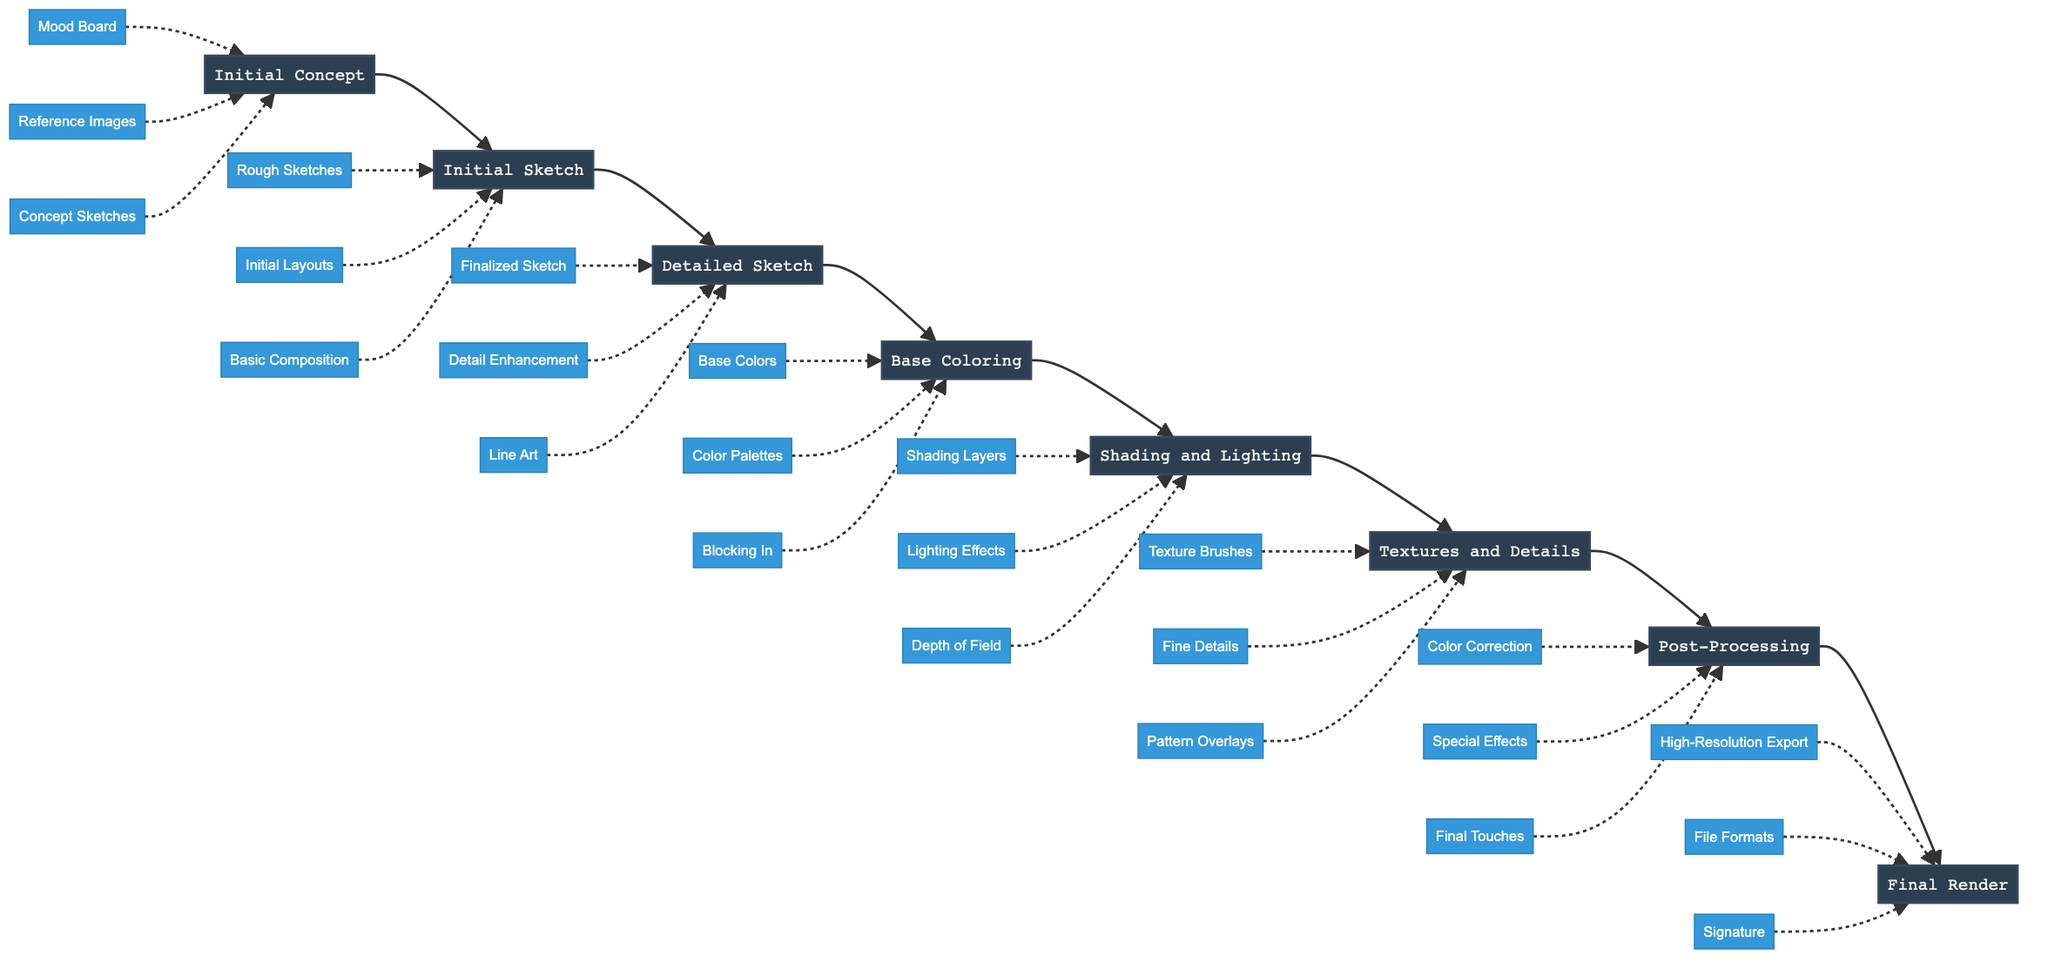What is the first stage in the digital art project pipeline? The first stage is the starting point of the flowchart, which is indicated as "Initial Concept." This is the first node in the diagram.
Answer: Initial Concept How many main stages are there in the pipeline? By counting the nodes representing the main stages, we find there are eight nodes: Initial Concept, Initial Sketch, Detailed Sketch, Base Coloring, Shading and Lighting, Textures and Details, Post-Processing, and Final Render.
Answer: 8 What entities are associated with the "Base Coloring" stage? The entities connected to the "Base Coloring" stage can be identified following the dashed lines from "Base Coloring," which leads to three entities: "Base Colors," "Color Palettes," and "Blocking In."
Answer: Base Colors, Color Palettes, Blocking In Which stage follows "Detailed Sketch"? To determine the subsequent stage, one can follow the flow of arrows from "Detailed Sketch." The next arrow points directly to "Base Coloring." Therefore, "Base Coloring" is the stage that follows it.
Answer: Base Coloring What is the last stage before the final render? The final render comes after various stages, and the stage immediately before it can be found by looking for the previous node connected to "Final Render." This stage is "Post-Processing."
Answer: Post-Processing Which entities support the "Shading and Lighting" stage? To find the entities that relate to "Shading and Lighting," I will trace the dashed lines leading away from this stage. They point to three entities: "Shading Layers," "Lighting Effects," and "Depth of Field."
Answer: Shading Layers, Lighting Effects, Depth of Field What is the main purpose of the "Initial Sketch" stage? The description for "Initial Sketch" can be found in the diagram. It defines that the purpose is to create first rough sketches to capture basic composition and forms. The purpose is stated directly in the node.
Answer: Creating first rough sketches How are the "Textures and Details" connected to the overall process? By following the flow from the preceding stages, "Textures and Details" comes after shading. The overall process leads from "Initial Concept" through various stages until it reaches "Final Render." Thus, "Textures and Details" contributes to enhancing the visual quality before the final output.
Answer: Enrich the visual quality What is the description of the "Post-Processing" stage? The specific details about "Post-Processing" can be extracted from the corresponding node. The description indicates that it involves final corrections and adjustments, applying effects, and polishing the artwork.
Answer: Final corrections and adjustments 